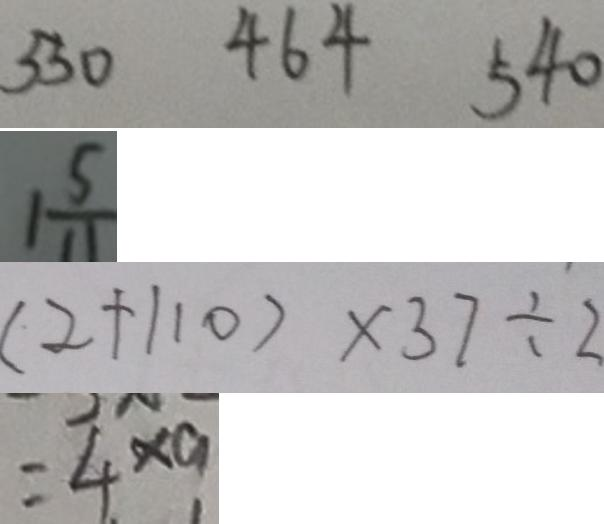Convert formula to latex. <formula><loc_0><loc_0><loc_500><loc_500>5 3 0 4 6 4 5 4 0 
 1 \frac { 5 } { 1 1 } 
 ( 2 + 1 1 0 ) \times 3 7 \div 2 
 = 4 \times 9</formula> 